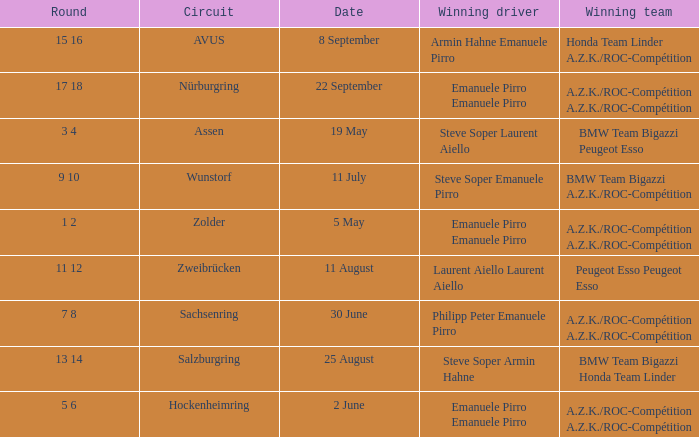What was the winning team on 11 July? BMW Team Bigazzi A.Z.K./ROC-Compétition. 